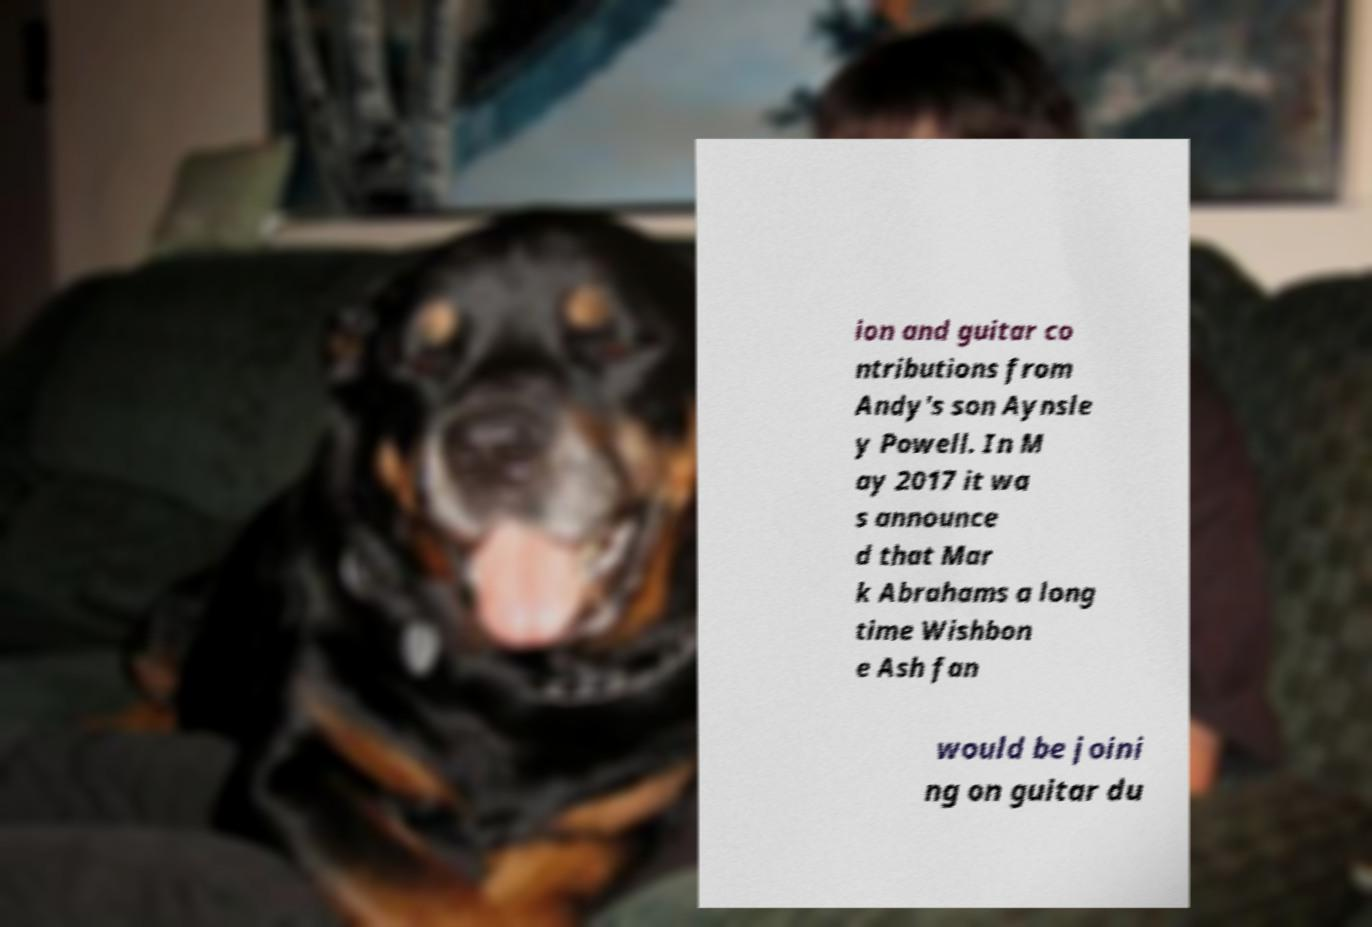Can you read and provide the text displayed in the image?This photo seems to have some interesting text. Can you extract and type it out for me? ion and guitar co ntributions from Andy's son Aynsle y Powell. In M ay 2017 it wa s announce d that Mar k Abrahams a long time Wishbon e Ash fan would be joini ng on guitar du 